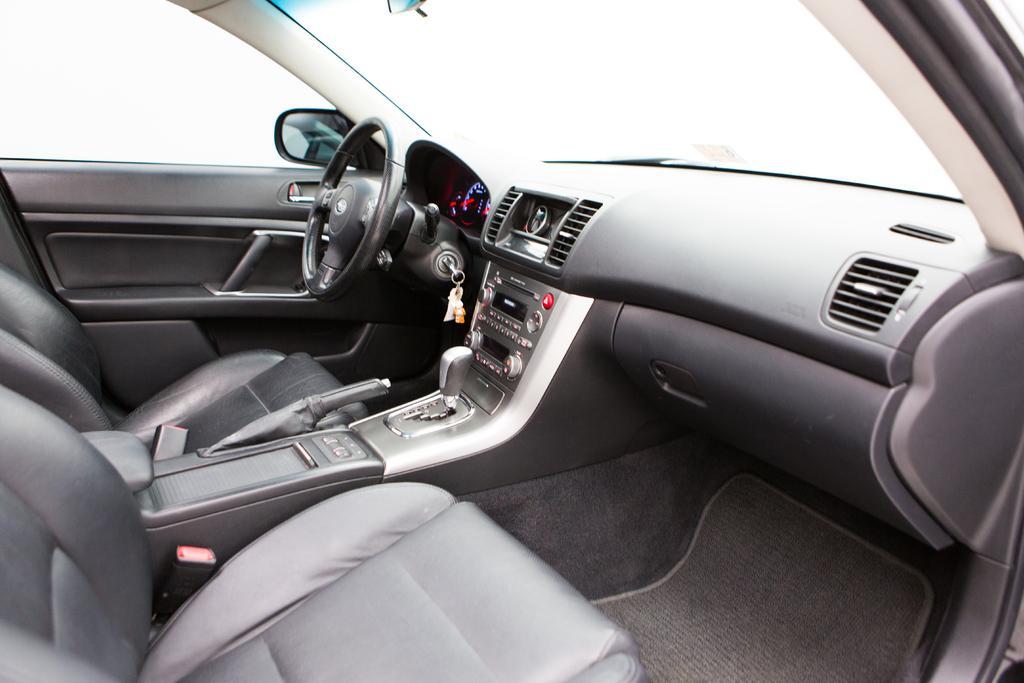How would you summarize this image in a sentence or two? In the picture we can see inside the car, inside we can see a steering, key near it and a gear and hand brake and seats and side mirror and music systems. 